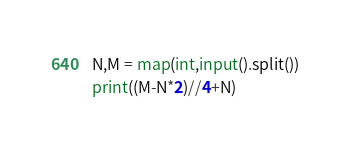<code> <loc_0><loc_0><loc_500><loc_500><_Python_>N,M = map(int,input().split())
print((M-N*2)//4+N)</code> 